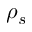<formula> <loc_0><loc_0><loc_500><loc_500>\rho _ { s }</formula> 